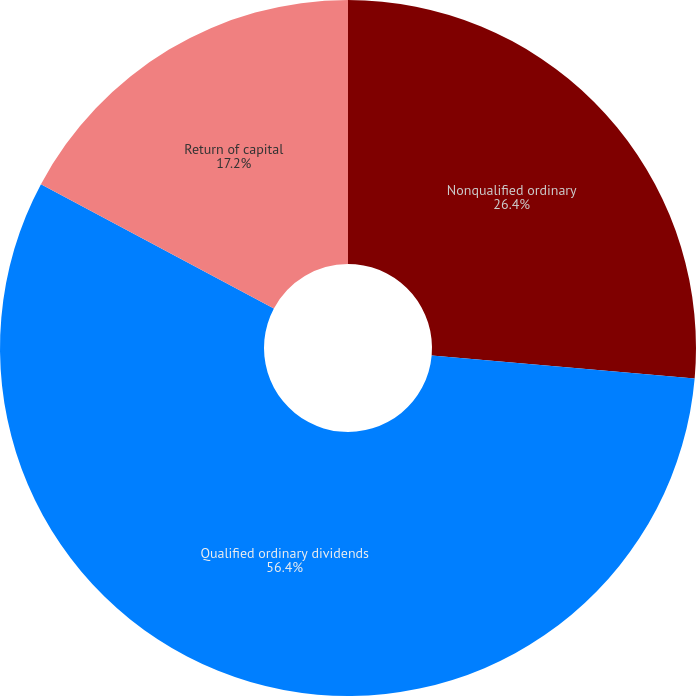Convert chart to OTSL. <chart><loc_0><loc_0><loc_500><loc_500><pie_chart><fcel>Nonqualified ordinary<fcel>Qualified ordinary dividends<fcel>Return of capital<nl><fcel>26.4%<fcel>56.4%<fcel>17.2%<nl></chart> 